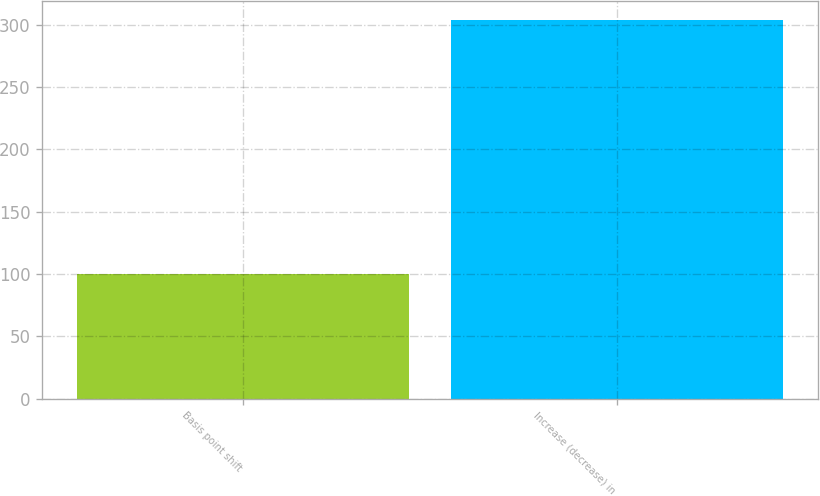<chart> <loc_0><loc_0><loc_500><loc_500><bar_chart><fcel>Basis point shift<fcel>Increase (decrease) in<nl><fcel>100<fcel>304<nl></chart> 